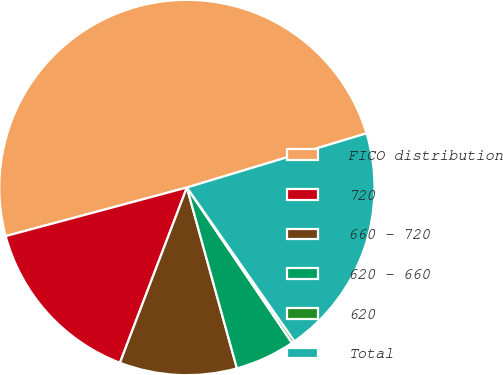Convert chart. <chart><loc_0><loc_0><loc_500><loc_500><pie_chart><fcel>FICO distribution<fcel>720<fcel>660 - 720<fcel>620 - 660<fcel>620<fcel>Total<nl><fcel>49.51%<fcel>15.02%<fcel>10.1%<fcel>5.17%<fcel>0.25%<fcel>19.95%<nl></chart> 